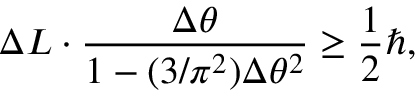<formula> <loc_0><loc_0><loc_500><loc_500>\Delta L \cdot \frac { \Delta \theta } { 1 - ( 3 / \pi ^ { 2 } ) \Delta \theta ^ { 2 } } \geq \frac { 1 } { 2 } \hbar { , }</formula> 